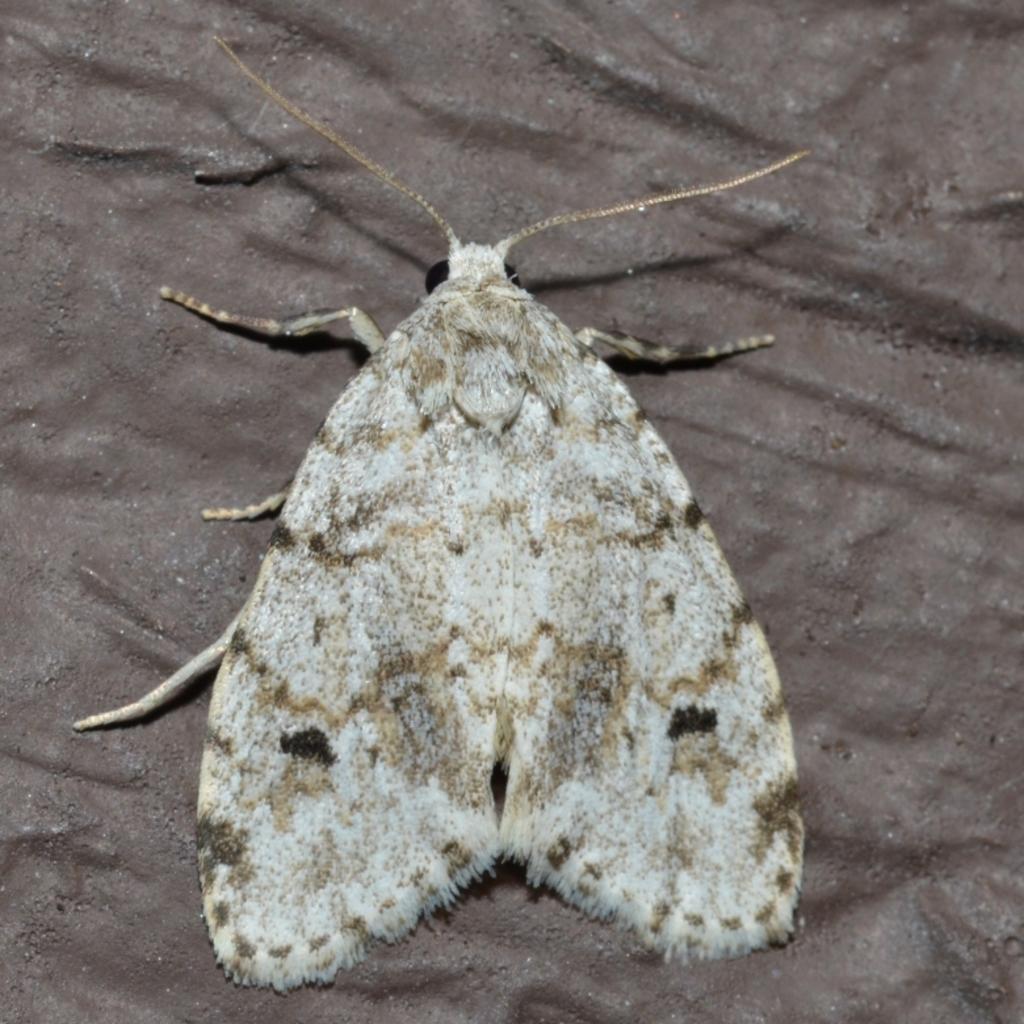Describe this image in one or two sentences. In the image there is a moth on the surface. 